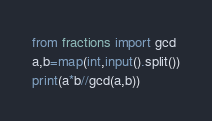<code> <loc_0><loc_0><loc_500><loc_500><_Python_>from fractions import gcd
a,b=map(int,input().split())
print(a*b//gcd(a,b))</code> 